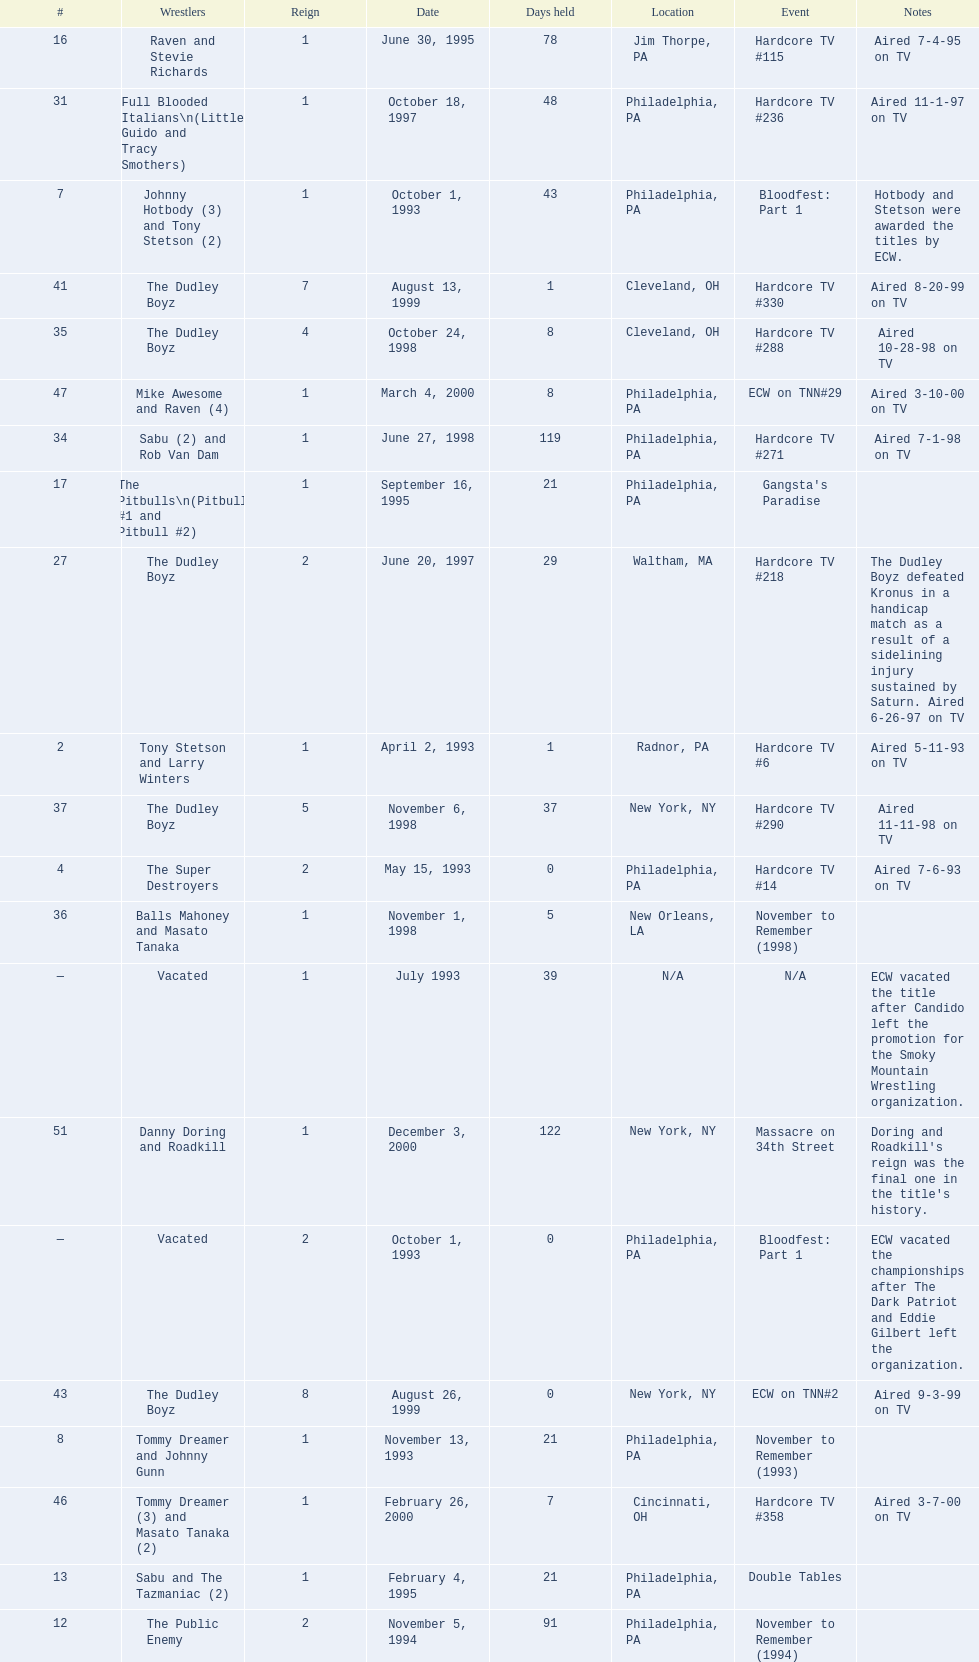What is the next event after hardcore tv #15? Hardcore TV #21. 